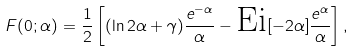Convert formula to latex. <formula><loc_0><loc_0><loc_500><loc_500>F ( 0 ; \alpha ) = \frac { 1 } { 2 } \left [ ( \ln 2 \alpha + \gamma ) \frac { e ^ { - \alpha } } { \alpha } - \text {Ei} [ - 2 \alpha ] \frac { e ^ { \alpha } } { \alpha } \right ] ,</formula> 